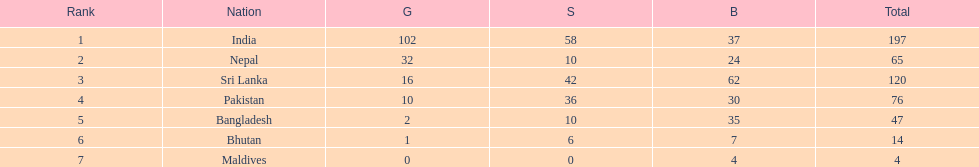How many gold medals were awarded between all 7 nations? 163. 